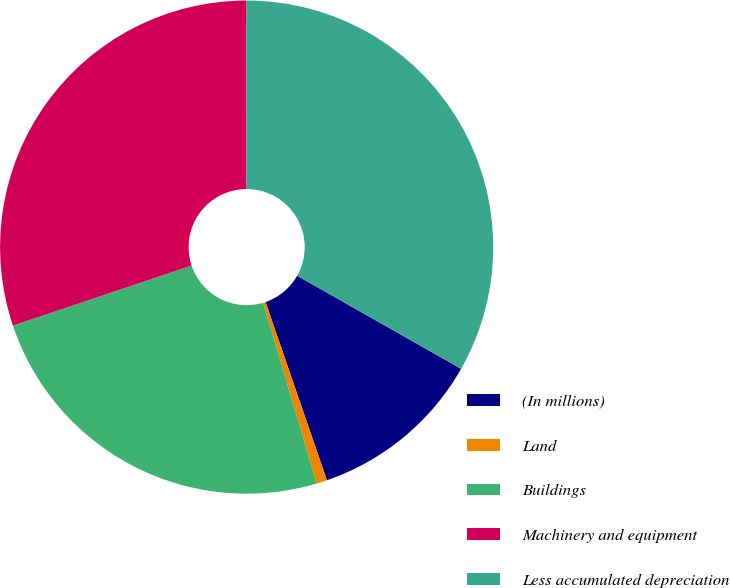<chart> <loc_0><loc_0><loc_500><loc_500><pie_chart><fcel>(In millions)<fcel>Land<fcel>Buildings<fcel>Machinery and equipment<fcel>Less accumulated depreciation<nl><fcel>11.51%<fcel>0.69%<fcel>24.43%<fcel>30.12%<fcel>33.25%<nl></chart> 